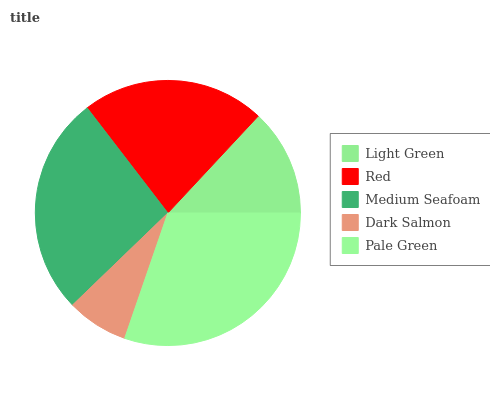Is Dark Salmon the minimum?
Answer yes or no. Yes. Is Pale Green the maximum?
Answer yes or no. Yes. Is Red the minimum?
Answer yes or no. No. Is Red the maximum?
Answer yes or no. No. Is Red greater than Light Green?
Answer yes or no. Yes. Is Light Green less than Red?
Answer yes or no. Yes. Is Light Green greater than Red?
Answer yes or no. No. Is Red less than Light Green?
Answer yes or no. No. Is Red the high median?
Answer yes or no. Yes. Is Red the low median?
Answer yes or no. Yes. Is Pale Green the high median?
Answer yes or no. No. Is Light Green the low median?
Answer yes or no. No. 